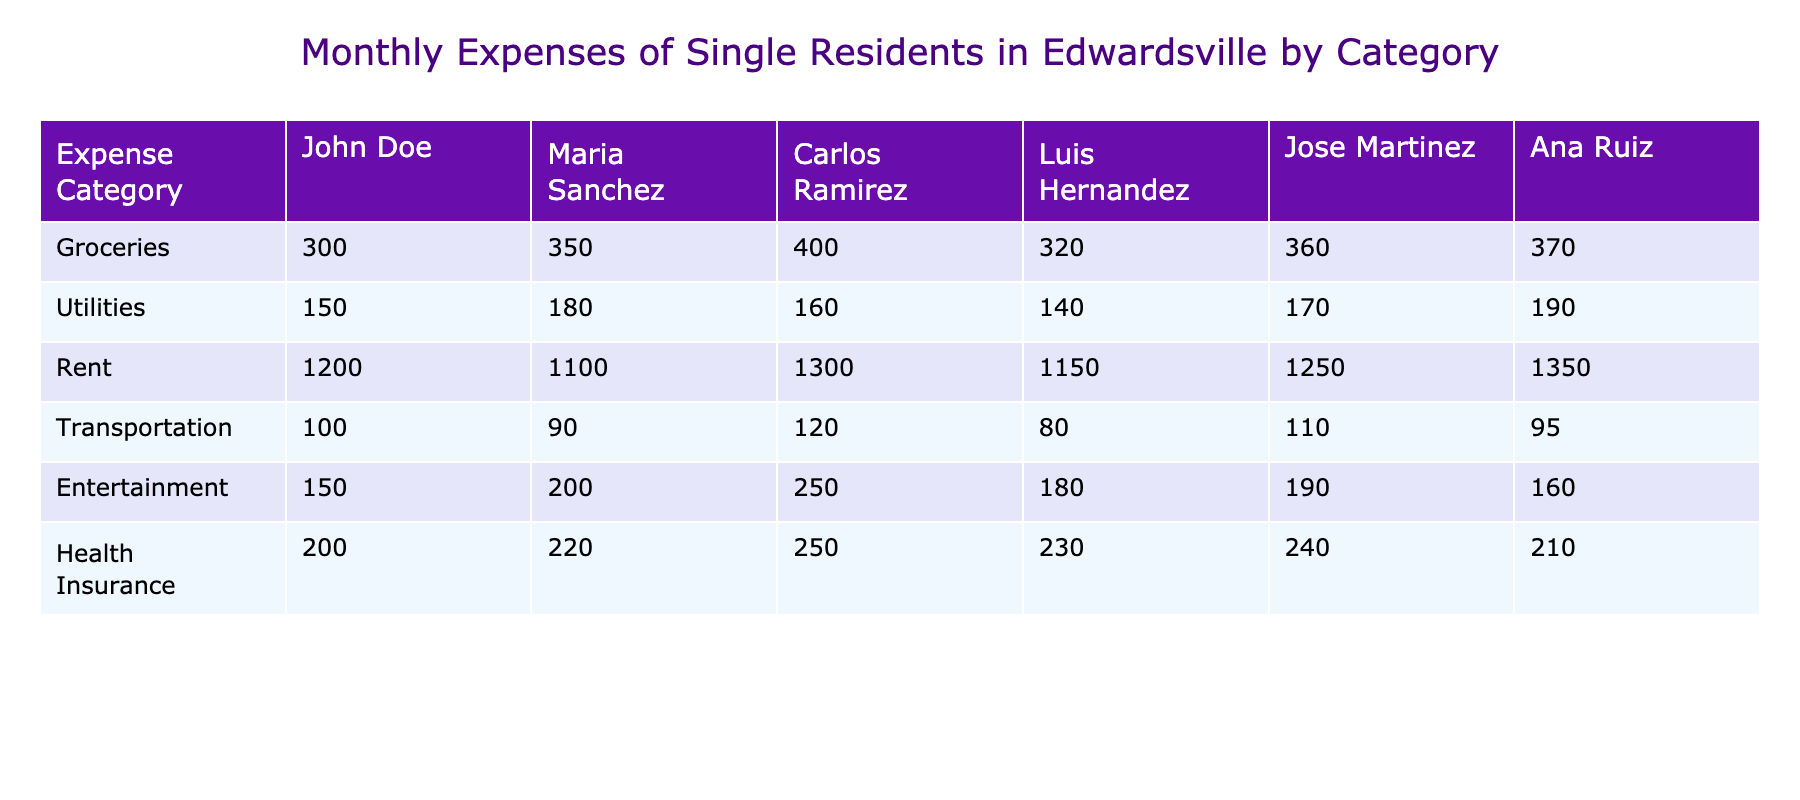What is Carlos Ramirez's total monthly expenses? To find the total monthly expenses for Carlos Ramirez, we need to sum up his expenses in each category: Groceries (400) + Utilities (160) + Rent (1300) + Transportation (120) + Entertainment (250) + Health Insurance (250) = 400 + 160 + 1300 + 120 + 250 + 250 = 2480.
Answer: 2480 Which resident has the highest transportation expense? Looking through the Transportation expenses of each resident, we find John Doe (100), Maria Sanchez (90), Carlos Ramirez (120), Luis Hernandez (80), Jose Martinez (110), and Ana Ruiz (95). The highest expense is from Carlos Ramirez (120).
Answer: Carlos Ramirez What is the average rent expense among the residents? To calculate the average rent, we add the Rent amounts: 1200 (John) + 1100 (Maria) + 1300 (Carlos) + 1150 (Luis) + 1250 (Jose) + 1350 (Ana) =  1200 + 1100 + 1300 + 1150 + 1250 + 1350 =  7350. There are 6 residents, so the average is 7350 / 6 = 1225.
Answer: 1225 Is Maria Sanchez's grocery expense higher than Ana Ruiz's? Comparing the grocery expenses, Maria Sanchez has 350 and Ana Ruiz has 370. Since 350 is not greater than 370, the answer is no.
Answer: No What is the difference in health insurance expenses between the highest and lowest spender? The highest health insurance expense is Carlos Ramirez (250) and the lowest is John Doe (200). The difference is calculated as 250 - 200 = 50.
Answer: 50 How much do the residents spend on health insurance in total? To find the total health insurance expense, we sum the expenses: 200 (John) + 220 (Maria) + 250 (Carlos) + 230 (Luis) + 240 (Jose) + 210 (Ana) = 200 + 220 + 250 + 230 + 240 + 210 = 1350.
Answer: 1350 Is it true that Jose Martinez spends more on Utilities than Luis Hernandez? Jose Martinez has a utility expense of 170, while Luis Hernandez has 140. Since 170 is greater than 140, the answer is yes.
Answer: Yes Which resident has the lowest total expenses? We can compute the total expenses for all residents: John (300 + 150 + 1200 + 100 + 150 + 200 = 2100), Maria (350 + 180 + 1100 + 90 + 200 + 220 = 2230), Carlos (400 + 160 + 1300 + 120 + 250 + 250 = 2480), Luis (320 + 140 + 1150 + 80 + 180 + 230 = 1100), Jose (360 + 170 + 1250 + 110 + 190 + 240 = 2320), Ana (370 + 190 + 1350 + 95 + 160 + 210 = 2375). The lowest total is John Doe at 2100.
Answer: John Doe 